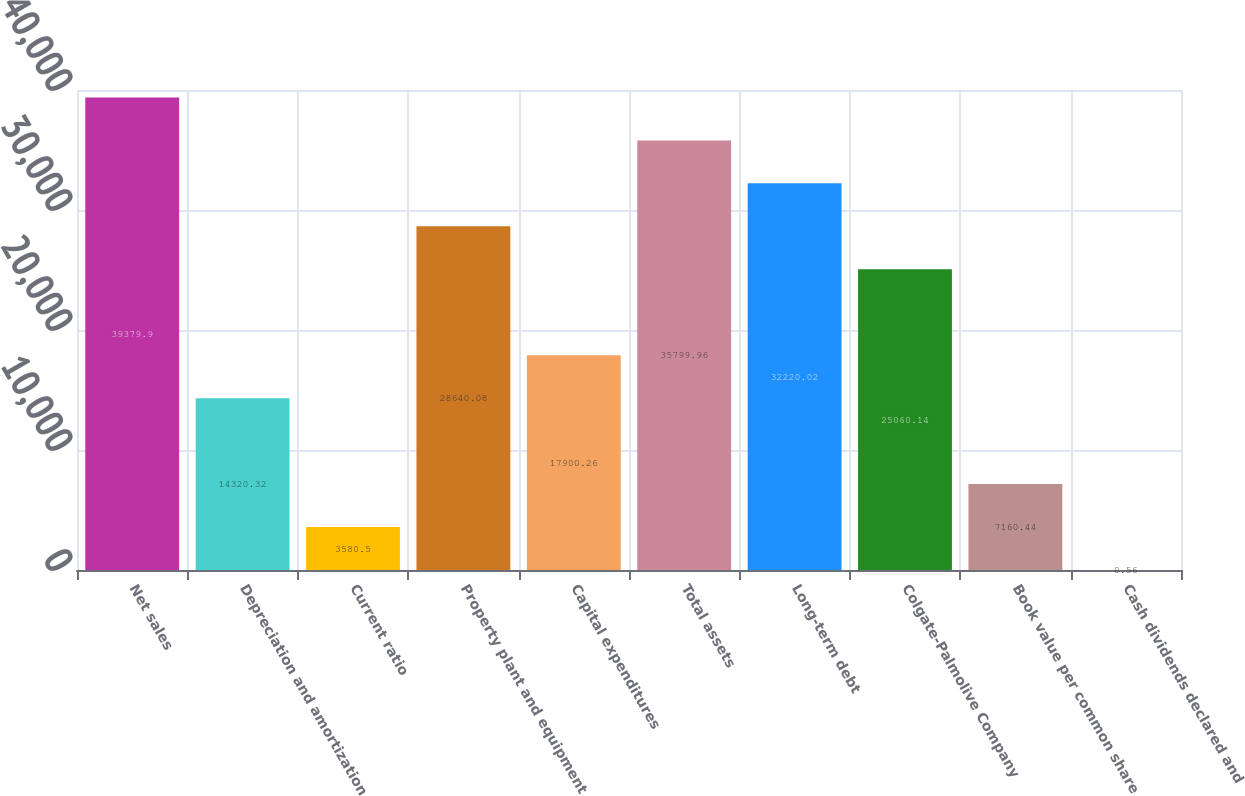Convert chart to OTSL. <chart><loc_0><loc_0><loc_500><loc_500><bar_chart><fcel>Net sales<fcel>Depreciation and amortization<fcel>Current ratio<fcel>Property plant and equipment<fcel>Capital expenditures<fcel>Total assets<fcel>Long-term debt<fcel>Colgate-Palmolive Company<fcel>Book value per common share<fcel>Cash dividends declared and<nl><fcel>39379.9<fcel>14320.3<fcel>3580.5<fcel>28640.1<fcel>17900.3<fcel>35800<fcel>32220<fcel>25060.1<fcel>7160.44<fcel>0.56<nl></chart> 